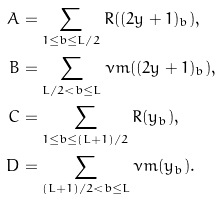<formula> <loc_0><loc_0><loc_500><loc_500>A & = \sum _ { 1 \leq b \leq L / 2 } R ( ( 2 y + 1 ) _ { b } ) , \\ B & = \sum _ { L / 2 < b \leq L } \nu m ( ( 2 y + 1 ) _ { b } ) , \\ C & = \sum _ { 1 \leq b \leq ( L + 1 ) / 2 } R ( y _ { b } ) , \\ D & = \sum _ { ( L + 1 ) / 2 < b \leq L } \nu m ( y _ { b } ) .</formula> 